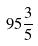<formula> <loc_0><loc_0><loc_500><loc_500>9 5 \frac { 3 } { 5 }</formula> 